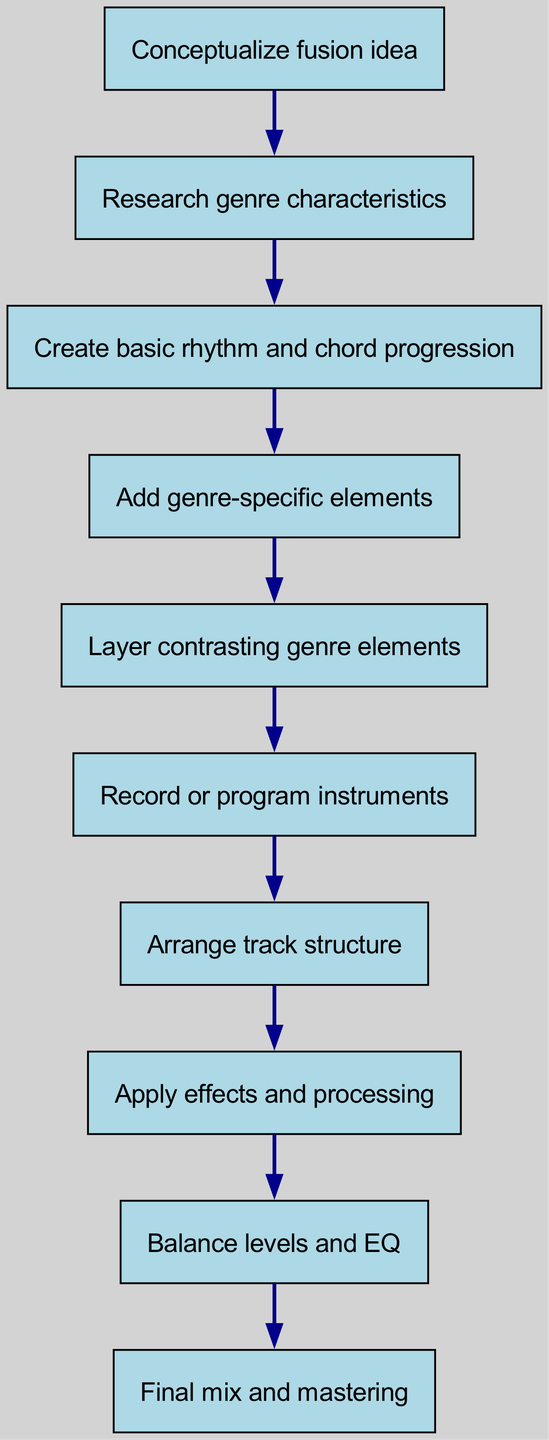What is the first step in the workflow? The first step listed in the diagram is "Conceptualize fusion idea", which is indicated as the starting point of the flow.
Answer: Conceptualize fusion idea How many nodes are in the diagram? The diagram includes ten nodes, each representing a step in the workflow process.
Answer: Ten Which step comes after "Layer contrasting genre elements"? The step that follows "Layer contrasting genre elements" is "Record or program instruments", as indicated by the directional flow in the diagram.
Answer: Record or program instruments What is the last step in the workflow? The final step listed in the diagram is "Final mix and mastering", marking the completion of the workflow.
Answer: Final mix and mastering What is the relationship between "Research genre characteristics" and "Create basic rhythm and chord progression"? The relationship is sequential; "Research genre characteristics" leads to "Create basic rhythm and chord progression", indicating that the latter is the next step after the former.
Answer: Sequential Which step involves adding specific elements to the track? The step where specific elements are added is "Add genre-specific elements", as shown in the diagram.
Answer: Add genre-specific elements What step involves adjusting levels and EQ? The step that focuses on adjusting levels and EQ is "Balance levels and EQ", which is a key part of the mixing process.
Answer: Balance levels and EQ How many steps are needed to reach the final mix and mastering? To reach "Final mix and mastering", there are nine earlier steps that must be completed, each leading sequentially toward the final step.
Answer: Nine What are the consecutive steps leading to "Apply effects and processing"? The steps leading to "Apply effects and processing" are "Arrange track structure" and "Add genre-specific elements", indicating the order of operations that culminate in applying effects.
Answer: Arrange track structure, Add genre-specific elements What type of flow does this diagram represent? This diagram represents a linear workflow, where each step flows into the next in a chronological order, illustrating the process of creating a genre-fusion track.
Answer: Linear workflow 